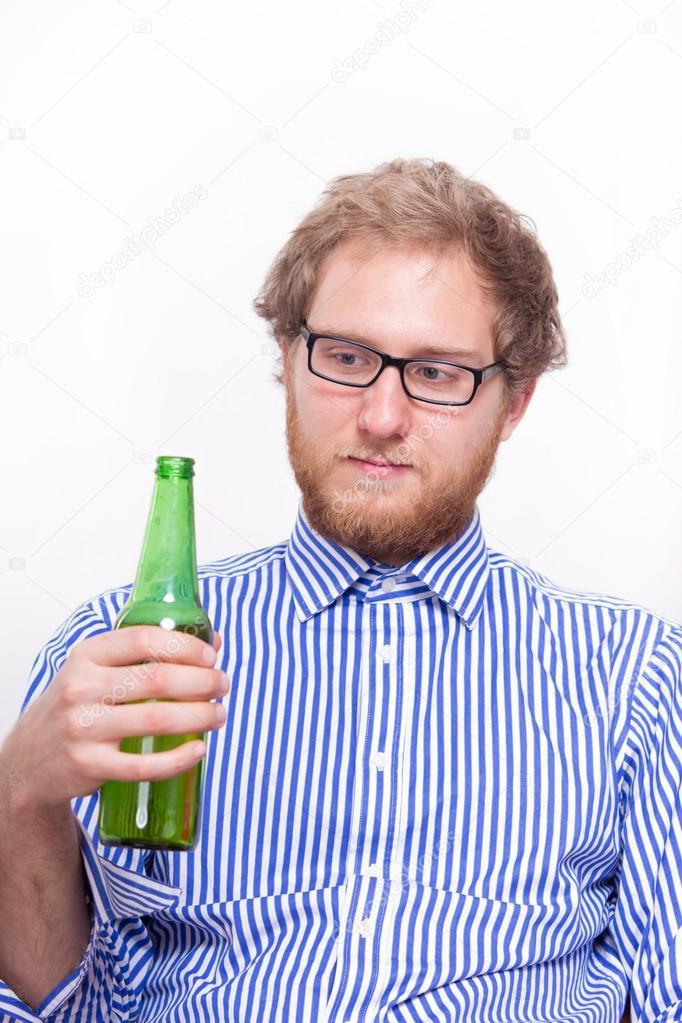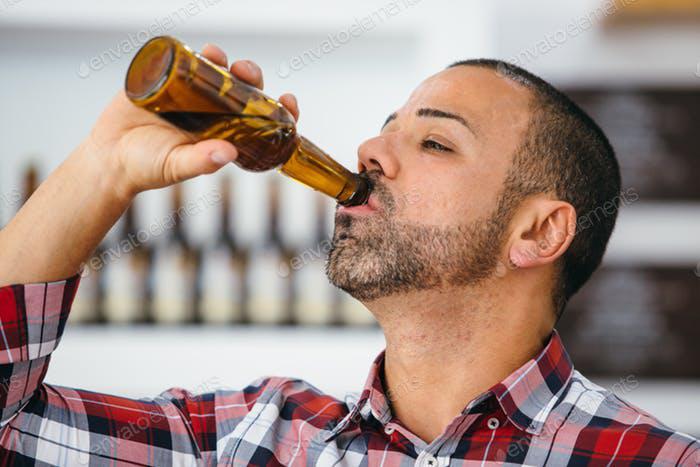The first image is the image on the left, the second image is the image on the right. Considering the images on both sides, is "The men in both images are drinking beer, touching the bottle to their lips." valid? Answer yes or no. No. The first image is the image on the left, the second image is the image on the right. Assess this claim about the two images: "There are exactly two bottles.". Correct or not? Answer yes or no. Yes. 